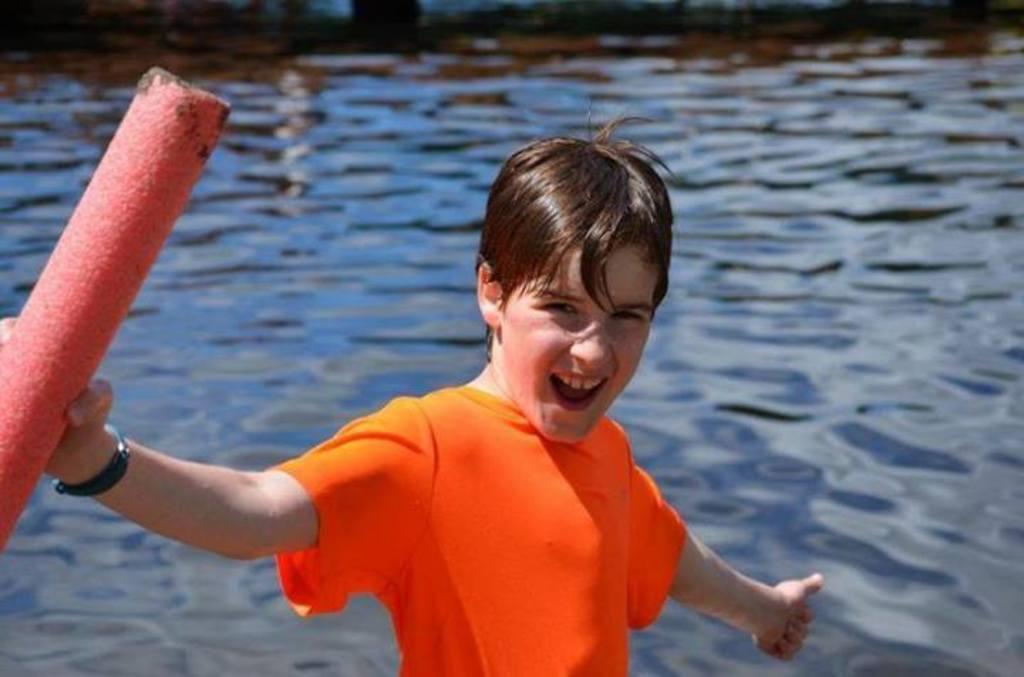Describe this image in one or two sentences. In this image we can see a boy holding an object. Behind the boy we can see the water. 